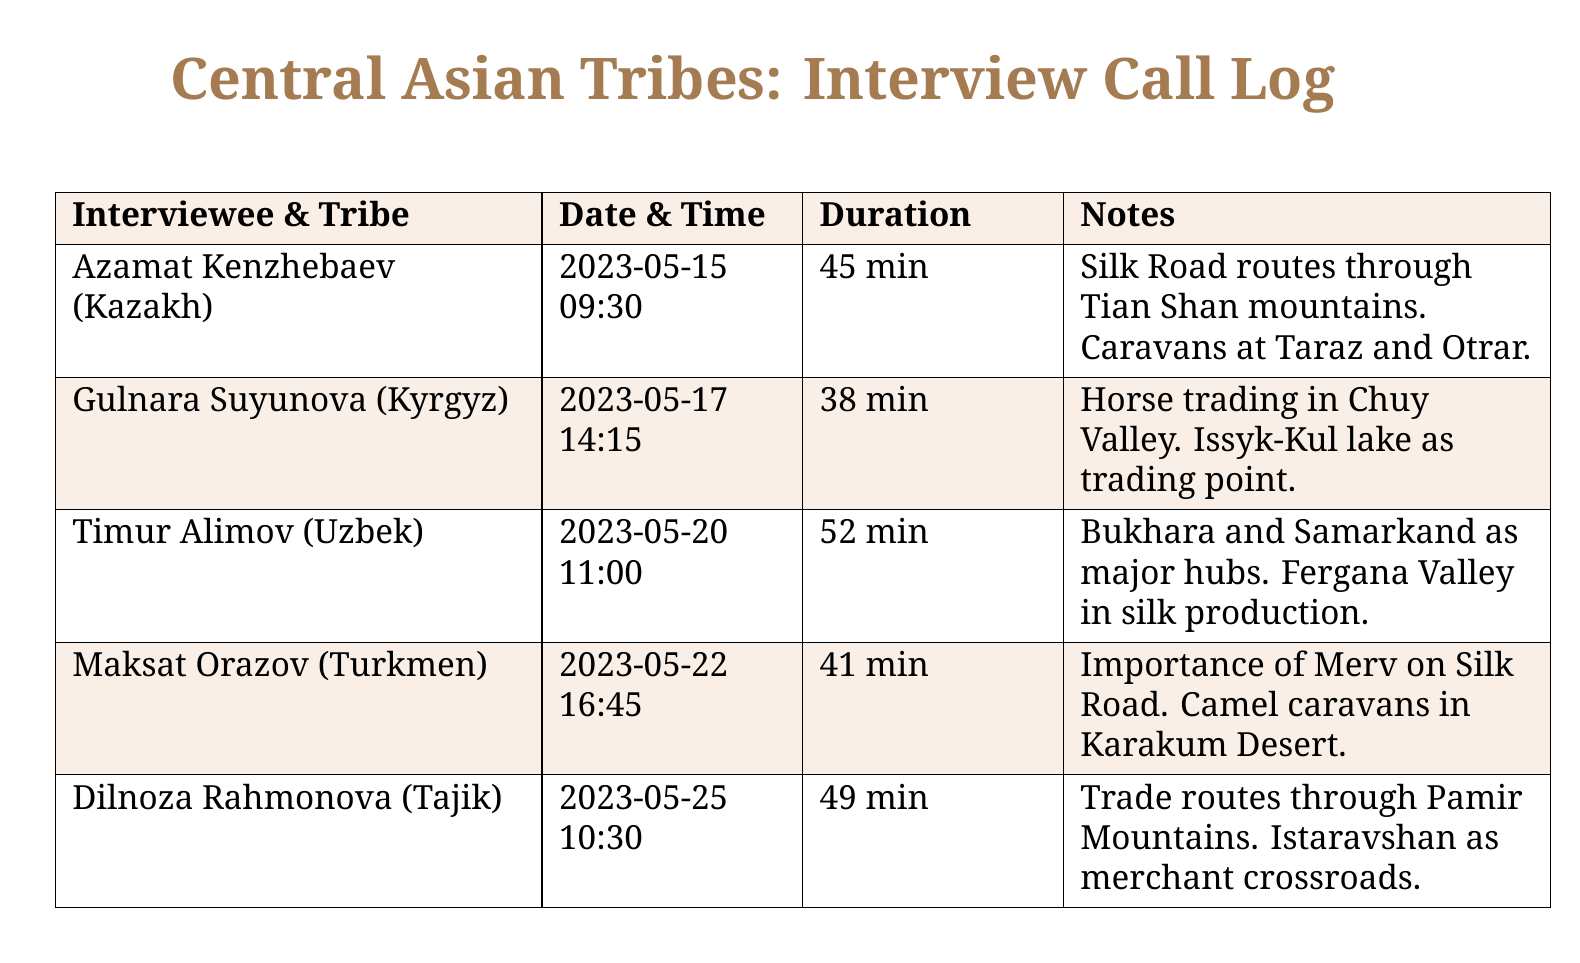What is the name of the first interviewee? The first interviewee listed in the document is Azamat Kenzhebaev.
Answer: Azamat Kenzhebaev What tribe does Gulnara Suyunova belong to? Gulnara Suyunova is identified as being from the Kyrgyz tribe in the document.
Answer: Kyrgyz What was the duration of the interview with Timur Alimov? The document specifies that Timur Alimov's interview lasted for 52 minutes.
Answer: 52 min On what date did the interview with Maksat Orazov take place? The interview with Maksat Orazov is recorded to have occurred on May 22, 2023.
Answer: 2023-05-22 Which major trading point was mentioned by Gulnara Suyunova? The document highlights Issyk-Kul lake as a significant trading point mentioned by Gulnara Suyunova.
Answer: Issyk-Kul lake What is the significance of Merv according to Maksat Orazov? Merv is described in the document as being important on the Silk Road.
Answer: Important on Silk Road How many minutes did Dilnoza Rahmonova's interview last? The document indicates that Dilnoza Rahmonova's interview lasted for 49 minutes.
Answer: 49 min Which route is Timur Alimov associated with? Timur Alimov is associated with the Silk production route through the Fergana Valley.
Answer: Fergana Valley For which purpose is the document compiled? The document is compiled for the study of Central Asian trading practices by an anthropology major.
Answer: Central Asian trading practices 